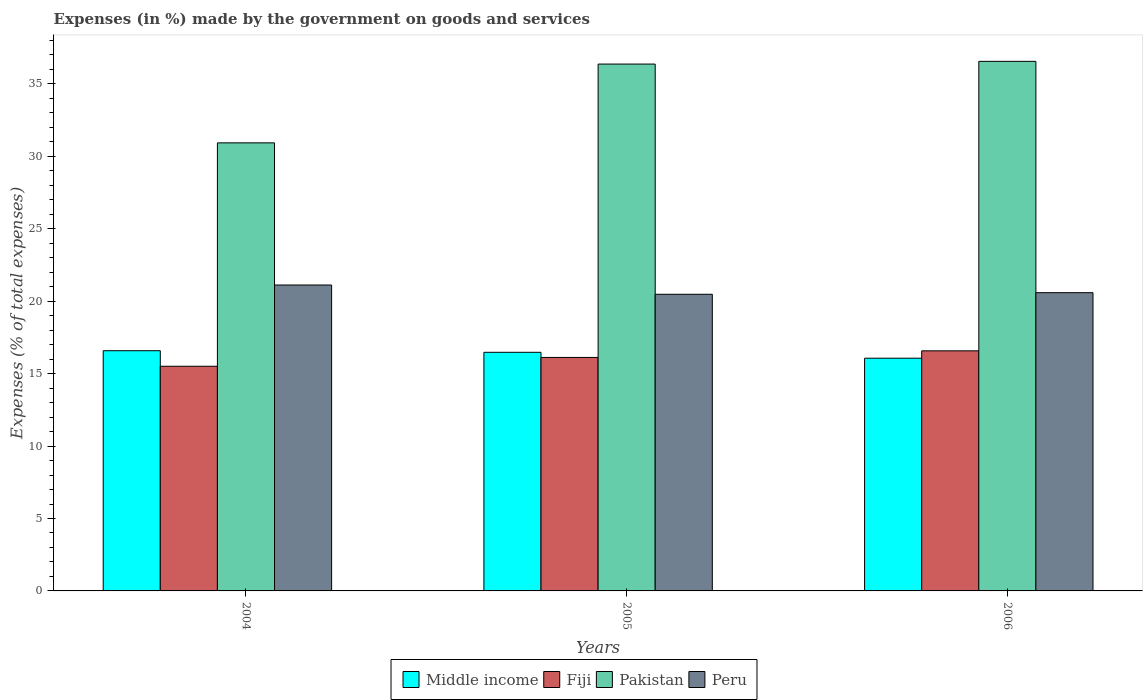Are the number of bars on each tick of the X-axis equal?
Provide a short and direct response. Yes. How many bars are there on the 3rd tick from the right?
Give a very brief answer. 4. What is the label of the 2nd group of bars from the left?
Keep it short and to the point. 2005. In how many cases, is the number of bars for a given year not equal to the number of legend labels?
Ensure brevity in your answer.  0. What is the percentage of expenses made by the government on goods and services in Pakistan in 2004?
Keep it short and to the point. 30.93. Across all years, what is the maximum percentage of expenses made by the government on goods and services in Peru?
Your answer should be compact. 21.12. Across all years, what is the minimum percentage of expenses made by the government on goods and services in Peru?
Keep it short and to the point. 20.48. In which year was the percentage of expenses made by the government on goods and services in Fiji maximum?
Give a very brief answer. 2006. In which year was the percentage of expenses made by the government on goods and services in Middle income minimum?
Your response must be concise. 2006. What is the total percentage of expenses made by the government on goods and services in Middle income in the graph?
Keep it short and to the point. 49.12. What is the difference between the percentage of expenses made by the government on goods and services in Peru in 2005 and that in 2006?
Your response must be concise. -0.11. What is the difference between the percentage of expenses made by the government on goods and services in Peru in 2005 and the percentage of expenses made by the government on goods and services in Pakistan in 2004?
Your response must be concise. -10.45. What is the average percentage of expenses made by the government on goods and services in Peru per year?
Offer a terse response. 20.73. In the year 2006, what is the difference between the percentage of expenses made by the government on goods and services in Peru and percentage of expenses made by the government on goods and services in Pakistan?
Your response must be concise. -15.97. What is the ratio of the percentage of expenses made by the government on goods and services in Pakistan in 2004 to that in 2005?
Your answer should be very brief. 0.85. Is the percentage of expenses made by the government on goods and services in Fiji in 2005 less than that in 2006?
Provide a short and direct response. Yes. What is the difference between the highest and the second highest percentage of expenses made by the government on goods and services in Pakistan?
Offer a very short reply. 0.19. What is the difference between the highest and the lowest percentage of expenses made by the government on goods and services in Pakistan?
Your answer should be compact. 5.63. In how many years, is the percentage of expenses made by the government on goods and services in Middle income greater than the average percentage of expenses made by the government on goods and services in Middle income taken over all years?
Offer a very short reply. 2. What does the 1st bar from the right in 2005 represents?
Ensure brevity in your answer.  Peru. How many bars are there?
Provide a succinct answer. 12. How many years are there in the graph?
Offer a terse response. 3. How many legend labels are there?
Make the answer very short. 4. How are the legend labels stacked?
Provide a short and direct response. Horizontal. What is the title of the graph?
Keep it short and to the point. Expenses (in %) made by the government on goods and services. What is the label or title of the Y-axis?
Ensure brevity in your answer.  Expenses (% of total expenses). What is the Expenses (% of total expenses) of Middle income in 2004?
Your answer should be compact. 16.58. What is the Expenses (% of total expenses) in Fiji in 2004?
Give a very brief answer. 15.51. What is the Expenses (% of total expenses) of Pakistan in 2004?
Your answer should be compact. 30.93. What is the Expenses (% of total expenses) in Peru in 2004?
Provide a short and direct response. 21.12. What is the Expenses (% of total expenses) in Middle income in 2005?
Offer a very short reply. 16.47. What is the Expenses (% of total expenses) in Fiji in 2005?
Offer a very short reply. 16.12. What is the Expenses (% of total expenses) of Pakistan in 2005?
Offer a very short reply. 36.37. What is the Expenses (% of total expenses) of Peru in 2005?
Provide a short and direct response. 20.48. What is the Expenses (% of total expenses) in Middle income in 2006?
Your answer should be compact. 16.07. What is the Expenses (% of total expenses) of Fiji in 2006?
Provide a succinct answer. 16.57. What is the Expenses (% of total expenses) in Pakistan in 2006?
Your answer should be compact. 36.56. What is the Expenses (% of total expenses) of Peru in 2006?
Offer a terse response. 20.59. Across all years, what is the maximum Expenses (% of total expenses) in Middle income?
Provide a short and direct response. 16.58. Across all years, what is the maximum Expenses (% of total expenses) in Fiji?
Your answer should be compact. 16.57. Across all years, what is the maximum Expenses (% of total expenses) of Pakistan?
Give a very brief answer. 36.56. Across all years, what is the maximum Expenses (% of total expenses) in Peru?
Your answer should be compact. 21.12. Across all years, what is the minimum Expenses (% of total expenses) of Middle income?
Your answer should be compact. 16.07. Across all years, what is the minimum Expenses (% of total expenses) of Fiji?
Your response must be concise. 15.51. Across all years, what is the minimum Expenses (% of total expenses) of Pakistan?
Provide a short and direct response. 30.93. Across all years, what is the minimum Expenses (% of total expenses) of Peru?
Offer a terse response. 20.48. What is the total Expenses (% of total expenses) in Middle income in the graph?
Ensure brevity in your answer.  49.12. What is the total Expenses (% of total expenses) in Fiji in the graph?
Your response must be concise. 48.2. What is the total Expenses (% of total expenses) of Pakistan in the graph?
Your answer should be very brief. 103.86. What is the total Expenses (% of total expenses) in Peru in the graph?
Offer a terse response. 62.19. What is the difference between the Expenses (% of total expenses) of Middle income in 2004 and that in 2005?
Give a very brief answer. 0.11. What is the difference between the Expenses (% of total expenses) of Fiji in 2004 and that in 2005?
Provide a short and direct response. -0.61. What is the difference between the Expenses (% of total expenses) of Pakistan in 2004 and that in 2005?
Give a very brief answer. -5.44. What is the difference between the Expenses (% of total expenses) in Peru in 2004 and that in 2005?
Make the answer very short. 0.64. What is the difference between the Expenses (% of total expenses) in Middle income in 2004 and that in 2006?
Provide a short and direct response. 0.52. What is the difference between the Expenses (% of total expenses) of Fiji in 2004 and that in 2006?
Offer a terse response. -1.06. What is the difference between the Expenses (% of total expenses) in Pakistan in 2004 and that in 2006?
Offer a terse response. -5.63. What is the difference between the Expenses (% of total expenses) of Peru in 2004 and that in 2006?
Your response must be concise. 0.53. What is the difference between the Expenses (% of total expenses) in Middle income in 2005 and that in 2006?
Your answer should be compact. 0.41. What is the difference between the Expenses (% of total expenses) of Fiji in 2005 and that in 2006?
Ensure brevity in your answer.  -0.46. What is the difference between the Expenses (% of total expenses) in Pakistan in 2005 and that in 2006?
Offer a terse response. -0.19. What is the difference between the Expenses (% of total expenses) in Peru in 2005 and that in 2006?
Offer a terse response. -0.11. What is the difference between the Expenses (% of total expenses) in Middle income in 2004 and the Expenses (% of total expenses) in Fiji in 2005?
Keep it short and to the point. 0.46. What is the difference between the Expenses (% of total expenses) in Middle income in 2004 and the Expenses (% of total expenses) in Pakistan in 2005?
Offer a terse response. -19.79. What is the difference between the Expenses (% of total expenses) in Middle income in 2004 and the Expenses (% of total expenses) in Peru in 2005?
Give a very brief answer. -3.9. What is the difference between the Expenses (% of total expenses) of Fiji in 2004 and the Expenses (% of total expenses) of Pakistan in 2005?
Ensure brevity in your answer.  -20.86. What is the difference between the Expenses (% of total expenses) of Fiji in 2004 and the Expenses (% of total expenses) of Peru in 2005?
Your response must be concise. -4.97. What is the difference between the Expenses (% of total expenses) in Pakistan in 2004 and the Expenses (% of total expenses) in Peru in 2005?
Your answer should be very brief. 10.45. What is the difference between the Expenses (% of total expenses) of Middle income in 2004 and the Expenses (% of total expenses) of Fiji in 2006?
Provide a succinct answer. 0.01. What is the difference between the Expenses (% of total expenses) of Middle income in 2004 and the Expenses (% of total expenses) of Pakistan in 2006?
Your answer should be very brief. -19.98. What is the difference between the Expenses (% of total expenses) in Middle income in 2004 and the Expenses (% of total expenses) in Peru in 2006?
Offer a terse response. -4.01. What is the difference between the Expenses (% of total expenses) in Fiji in 2004 and the Expenses (% of total expenses) in Pakistan in 2006?
Your answer should be very brief. -21.05. What is the difference between the Expenses (% of total expenses) of Fiji in 2004 and the Expenses (% of total expenses) of Peru in 2006?
Keep it short and to the point. -5.08. What is the difference between the Expenses (% of total expenses) of Pakistan in 2004 and the Expenses (% of total expenses) of Peru in 2006?
Make the answer very short. 10.34. What is the difference between the Expenses (% of total expenses) of Middle income in 2005 and the Expenses (% of total expenses) of Fiji in 2006?
Keep it short and to the point. -0.1. What is the difference between the Expenses (% of total expenses) in Middle income in 2005 and the Expenses (% of total expenses) in Pakistan in 2006?
Ensure brevity in your answer.  -20.09. What is the difference between the Expenses (% of total expenses) in Middle income in 2005 and the Expenses (% of total expenses) in Peru in 2006?
Give a very brief answer. -4.12. What is the difference between the Expenses (% of total expenses) in Fiji in 2005 and the Expenses (% of total expenses) in Pakistan in 2006?
Provide a short and direct response. -20.44. What is the difference between the Expenses (% of total expenses) of Fiji in 2005 and the Expenses (% of total expenses) of Peru in 2006?
Ensure brevity in your answer.  -4.47. What is the difference between the Expenses (% of total expenses) of Pakistan in 2005 and the Expenses (% of total expenses) of Peru in 2006?
Provide a succinct answer. 15.78. What is the average Expenses (% of total expenses) of Middle income per year?
Provide a succinct answer. 16.37. What is the average Expenses (% of total expenses) in Fiji per year?
Ensure brevity in your answer.  16.07. What is the average Expenses (% of total expenses) in Pakistan per year?
Give a very brief answer. 34.62. What is the average Expenses (% of total expenses) in Peru per year?
Offer a terse response. 20.73. In the year 2004, what is the difference between the Expenses (% of total expenses) in Middle income and Expenses (% of total expenses) in Fiji?
Your response must be concise. 1.07. In the year 2004, what is the difference between the Expenses (% of total expenses) of Middle income and Expenses (% of total expenses) of Pakistan?
Make the answer very short. -14.35. In the year 2004, what is the difference between the Expenses (% of total expenses) in Middle income and Expenses (% of total expenses) in Peru?
Your answer should be compact. -4.54. In the year 2004, what is the difference between the Expenses (% of total expenses) in Fiji and Expenses (% of total expenses) in Pakistan?
Your response must be concise. -15.42. In the year 2004, what is the difference between the Expenses (% of total expenses) of Fiji and Expenses (% of total expenses) of Peru?
Offer a terse response. -5.61. In the year 2004, what is the difference between the Expenses (% of total expenses) of Pakistan and Expenses (% of total expenses) of Peru?
Offer a terse response. 9.81. In the year 2005, what is the difference between the Expenses (% of total expenses) of Middle income and Expenses (% of total expenses) of Fiji?
Provide a succinct answer. 0.35. In the year 2005, what is the difference between the Expenses (% of total expenses) of Middle income and Expenses (% of total expenses) of Pakistan?
Your response must be concise. -19.9. In the year 2005, what is the difference between the Expenses (% of total expenses) of Middle income and Expenses (% of total expenses) of Peru?
Provide a succinct answer. -4.01. In the year 2005, what is the difference between the Expenses (% of total expenses) of Fiji and Expenses (% of total expenses) of Pakistan?
Offer a terse response. -20.25. In the year 2005, what is the difference between the Expenses (% of total expenses) in Fiji and Expenses (% of total expenses) in Peru?
Provide a succinct answer. -4.36. In the year 2005, what is the difference between the Expenses (% of total expenses) in Pakistan and Expenses (% of total expenses) in Peru?
Keep it short and to the point. 15.89. In the year 2006, what is the difference between the Expenses (% of total expenses) of Middle income and Expenses (% of total expenses) of Fiji?
Provide a succinct answer. -0.51. In the year 2006, what is the difference between the Expenses (% of total expenses) of Middle income and Expenses (% of total expenses) of Pakistan?
Make the answer very short. -20.49. In the year 2006, what is the difference between the Expenses (% of total expenses) in Middle income and Expenses (% of total expenses) in Peru?
Provide a succinct answer. -4.52. In the year 2006, what is the difference between the Expenses (% of total expenses) of Fiji and Expenses (% of total expenses) of Pakistan?
Make the answer very short. -19.98. In the year 2006, what is the difference between the Expenses (% of total expenses) in Fiji and Expenses (% of total expenses) in Peru?
Your answer should be very brief. -4.01. In the year 2006, what is the difference between the Expenses (% of total expenses) of Pakistan and Expenses (% of total expenses) of Peru?
Ensure brevity in your answer.  15.97. What is the ratio of the Expenses (% of total expenses) of Fiji in 2004 to that in 2005?
Your answer should be compact. 0.96. What is the ratio of the Expenses (% of total expenses) of Pakistan in 2004 to that in 2005?
Offer a very short reply. 0.85. What is the ratio of the Expenses (% of total expenses) of Peru in 2004 to that in 2005?
Your answer should be very brief. 1.03. What is the ratio of the Expenses (% of total expenses) of Middle income in 2004 to that in 2006?
Make the answer very short. 1.03. What is the ratio of the Expenses (% of total expenses) in Fiji in 2004 to that in 2006?
Give a very brief answer. 0.94. What is the ratio of the Expenses (% of total expenses) in Pakistan in 2004 to that in 2006?
Provide a short and direct response. 0.85. What is the ratio of the Expenses (% of total expenses) of Peru in 2004 to that in 2006?
Keep it short and to the point. 1.03. What is the ratio of the Expenses (% of total expenses) in Middle income in 2005 to that in 2006?
Offer a terse response. 1.03. What is the ratio of the Expenses (% of total expenses) of Fiji in 2005 to that in 2006?
Give a very brief answer. 0.97. What is the difference between the highest and the second highest Expenses (% of total expenses) of Middle income?
Provide a succinct answer. 0.11. What is the difference between the highest and the second highest Expenses (% of total expenses) of Fiji?
Your answer should be very brief. 0.46. What is the difference between the highest and the second highest Expenses (% of total expenses) of Pakistan?
Make the answer very short. 0.19. What is the difference between the highest and the second highest Expenses (% of total expenses) of Peru?
Ensure brevity in your answer.  0.53. What is the difference between the highest and the lowest Expenses (% of total expenses) in Middle income?
Provide a short and direct response. 0.52. What is the difference between the highest and the lowest Expenses (% of total expenses) in Fiji?
Provide a succinct answer. 1.06. What is the difference between the highest and the lowest Expenses (% of total expenses) of Pakistan?
Offer a terse response. 5.63. What is the difference between the highest and the lowest Expenses (% of total expenses) of Peru?
Keep it short and to the point. 0.64. 